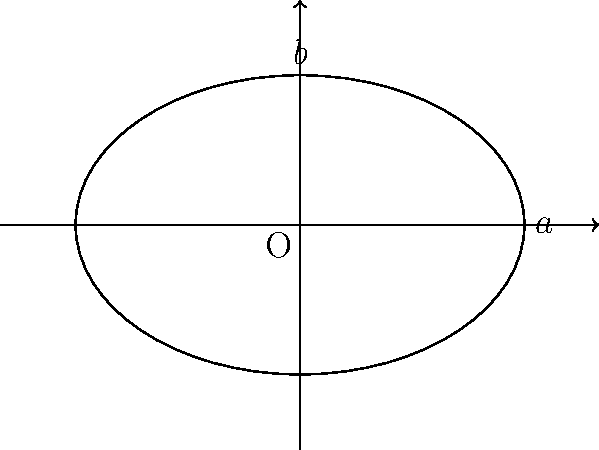As an actor, you're preparing for a dramatic scene where you'll be illuminated by an elliptical spotlight on stage. The spotlight's projection on the flat stage floor forms an ellipse with a major axis of 6 meters and a minor axis of 4 meters. What is the area of the elliptical spotlight projection on the stage floor? To solve this problem, we'll follow these steps:

1. Recall the formula for the area of an ellipse: $A = \pi ab$, where $a$ and $b$ are the lengths of the semi-major and semi-minor axes, respectively.

2. Identify the given information:
   - Major axis = 6 meters
   - Minor axis = 4 meters

3. Calculate the semi-major and semi-minor axes:
   - Semi-major axis (a) = 6 ÷ 2 = 3 meters
   - Semi-minor axis (b) = 4 ÷ 2 = 2 meters

4. Apply the formula:
   $A = \pi ab$
   $A = \pi (3)(2)$
   $A = 6\pi$ square meters

5. Simplify the result:
   $A \approx 18.85$ square meters (rounded to two decimal places)

As an actor, understanding the size of your illuminated area can help you plan your movements and positioning on stage for maximum dramatic effect.
Answer: $6\pi$ sq. meters (or approximately 18.85 sq. meters) 